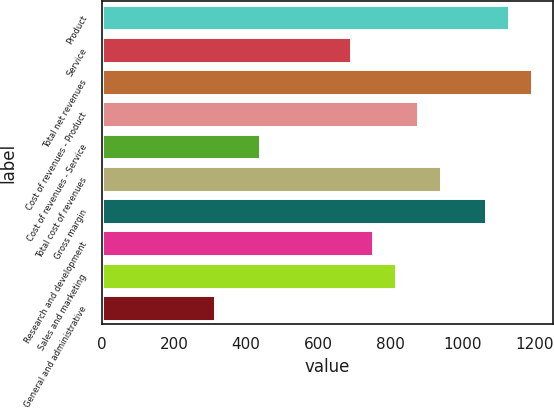Convert chart. <chart><loc_0><loc_0><loc_500><loc_500><bar_chart><fcel>Product<fcel>Service<fcel>Total net revenues<fcel>Cost of revenues - Product<fcel>Cost of revenues - Service<fcel>Total cost of revenues<fcel>Gross margin<fcel>Research and development<fcel>Sales and marketing<fcel>General and administrative<nl><fcel>1128.35<fcel>689.59<fcel>1191.03<fcel>877.63<fcel>438.87<fcel>940.31<fcel>1065.67<fcel>752.27<fcel>814.95<fcel>313.51<nl></chart> 